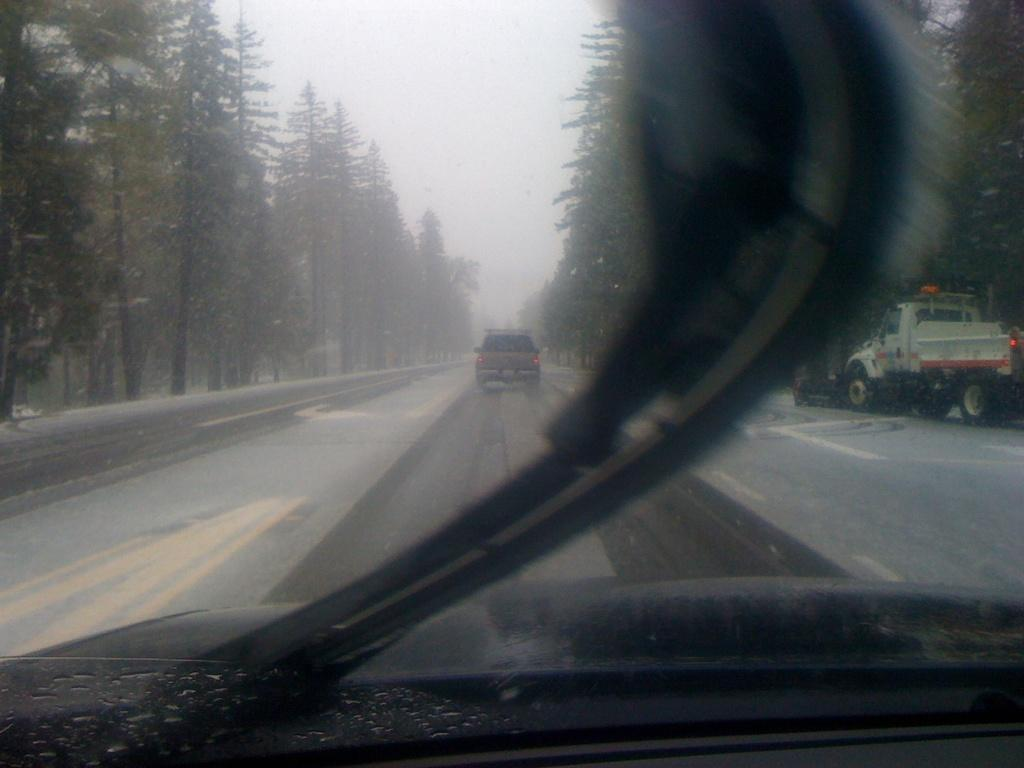What can be seen on the road in the image? There are vehicles on the road in the image. What type of vegetation is present alongside the road? Trees are present on either side of the road in the image. How many eyes can be seen on the coat in the image? There is no coat or eyes present in the image; it features vehicles on a road with trees on either side. 